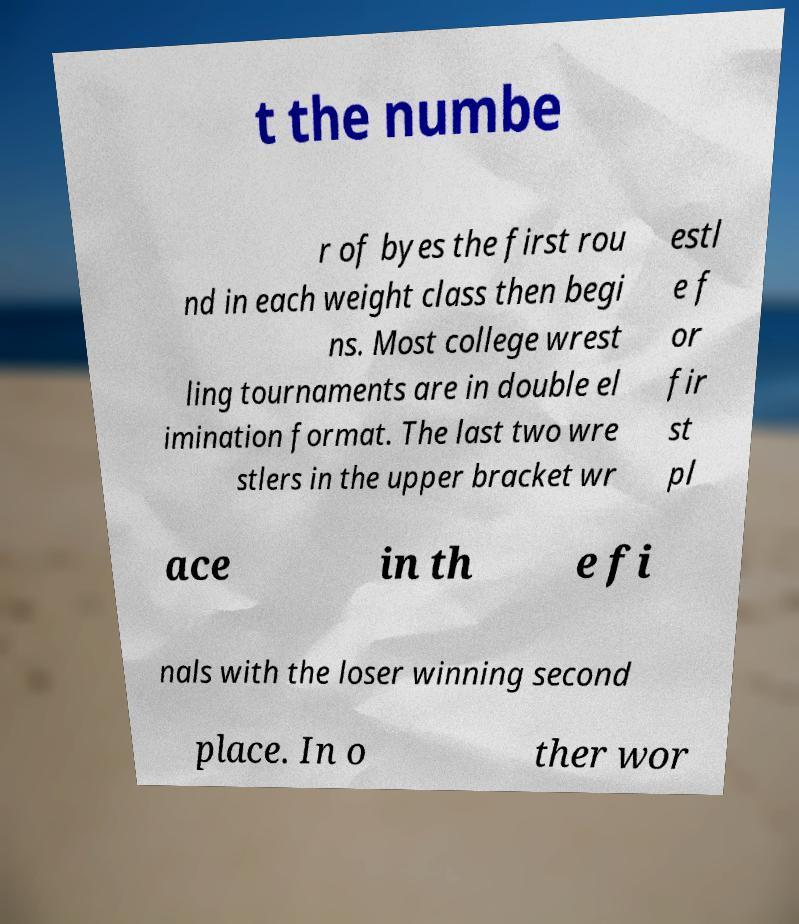Can you accurately transcribe the text from the provided image for me? t the numbe r of byes the first rou nd in each weight class then begi ns. Most college wrest ling tournaments are in double el imination format. The last two wre stlers in the upper bracket wr estl e f or fir st pl ace in th e fi nals with the loser winning second place. In o ther wor 